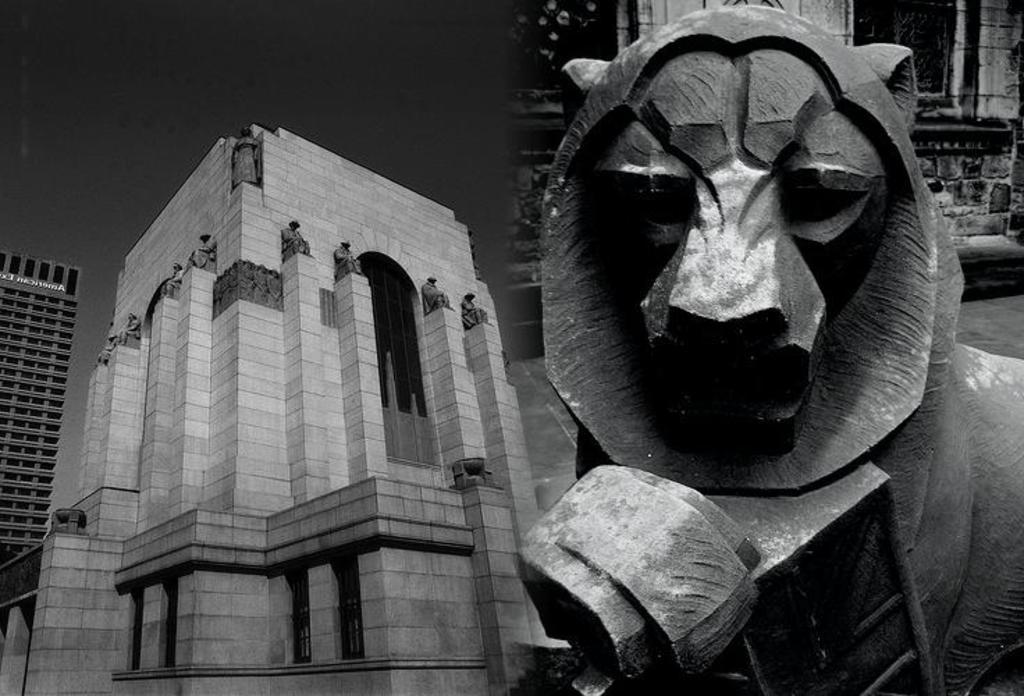What type of structures are present in the image? There are tall buildings in the image. What kind of artwork can be seen on the right side of the image? There is an animal face sculpture on the right side of the image. What part of the natural environment is visible in the image? The sky is visible in the image. What type of authority figure can be seen in the image? There is no authority figure present in the image. How many women are visible in the image? There is no mention of women in the provided facts, so we cannot determine their presence in the image. 